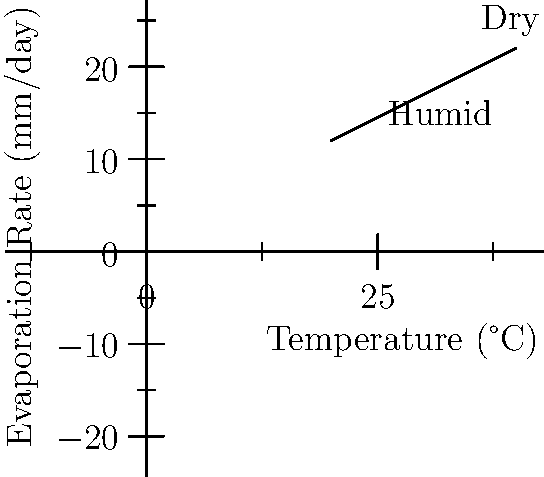A luxury resort in Seychelles is considering installing a new outdoor pool. The graph shows the evaporation rate of water from a pool surface under different atmospheric conditions. If the average daytime temperature increases from 25°C to 35°C, by approximately how much does the evaporation rate increase in dry conditions compared to humid conditions? To solve this problem, we need to follow these steps:

1. Identify the evaporation rates at 25°C and 35°C for both humid and dry conditions.

2. Calculate the increase in evaporation rate for each condition:
   a) For humid conditions:
      At 25°C: $0.5 \times 25 + 2 = 14.5$ mm/day
      At 35°C: $0.5 \times 35 + 2 = 19.5$ mm/day
      Increase: $19.5 - 14.5 = 5$ mm/day

   b) For dry conditions:
      At 25°C: $0.5 \times 25 + 2 = 14.5$ mm/day
      At 35°C: $0.5 \times 35 + 2 = 19.5$ mm/day
      Increase: $19.5 - 14.5 = 5$ mm/day

3. Compare the increases:
   The increase is the same for both conditions: 5 mm/day

Therefore, the evaporation rate increases by the same amount in both dry and humid conditions.
Answer: 0 mm/day 